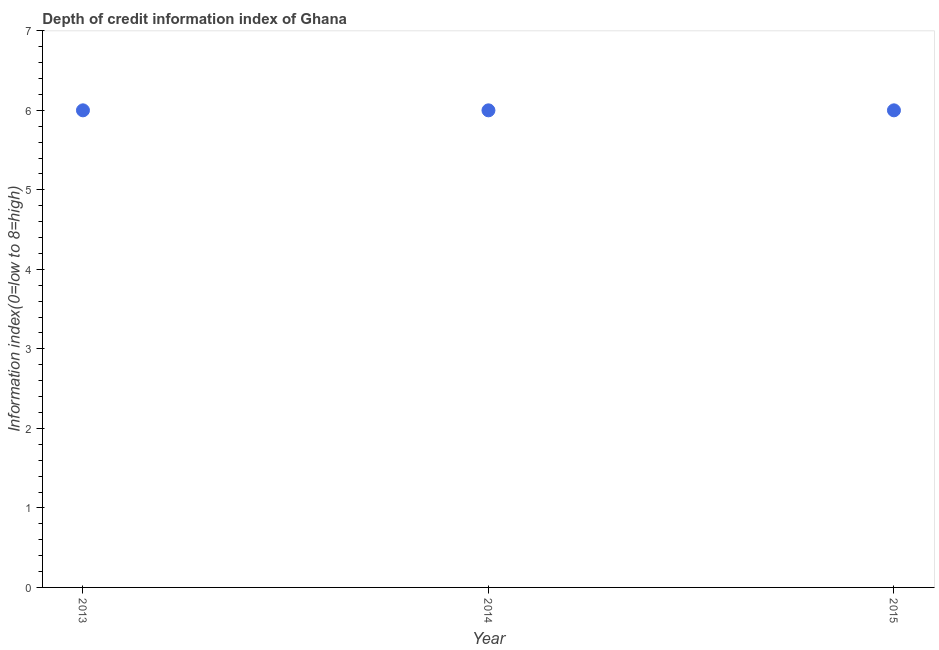Across all years, what is the maximum depth of credit information index?
Provide a succinct answer. 6. Across all years, what is the minimum depth of credit information index?
Your response must be concise. 6. In which year was the depth of credit information index maximum?
Offer a very short reply. 2013. What is the sum of the depth of credit information index?
Offer a terse response. 18. What is the difference between the depth of credit information index in 2014 and 2015?
Provide a short and direct response. 0. In how many years, is the depth of credit information index greater than 3.8 ?
Keep it short and to the point. 3. Is the depth of credit information index in 2013 less than that in 2015?
Your response must be concise. No. What is the difference between the highest and the second highest depth of credit information index?
Your answer should be very brief. 0. Is the sum of the depth of credit information index in 2013 and 2014 greater than the maximum depth of credit information index across all years?
Keep it short and to the point. Yes. In how many years, is the depth of credit information index greater than the average depth of credit information index taken over all years?
Your answer should be compact. 0. Does the depth of credit information index monotonically increase over the years?
Provide a short and direct response. No. How many dotlines are there?
Your answer should be compact. 1. Are the values on the major ticks of Y-axis written in scientific E-notation?
Make the answer very short. No. Does the graph contain grids?
Keep it short and to the point. No. What is the title of the graph?
Provide a short and direct response. Depth of credit information index of Ghana. What is the label or title of the Y-axis?
Ensure brevity in your answer.  Information index(0=low to 8=high). What is the Information index(0=low to 8=high) in 2014?
Make the answer very short. 6. What is the Information index(0=low to 8=high) in 2015?
Your answer should be compact. 6. What is the difference between the Information index(0=low to 8=high) in 2013 and 2014?
Give a very brief answer. 0. What is the difference between the Information index(0=low to 8=high) in 2013 and 2015?
Provide a succinct answer. 0. What is the difference between the Information index(0=low to 8=high) in 2014 and 2015?
Provide a succinct answer. 0. What is the ratio of the Information index(0=low to 8=high) in 2013 to that in 2014?
Ensure brevity in your answer.  1. What is the ratio of the Information index(0=low to 8=high) in 2013 to that in 2015?
Provide a succinct answer. 1. 